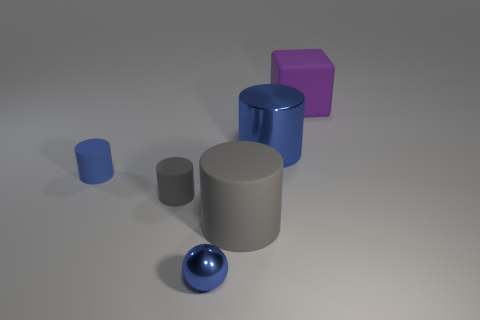Add 4 tiny cyan metal cubes. How many objects exist? 10 Subtract all blocks. How many objects are left? 5 Subtract 0 yellow cubes. How many objects are left? 6 Subtract all large matte cylinders. Subtract all rubber cylinders. How many objects are left? 2 Add 6 rubber things. How many rubber things are left? 10 Add 3 blue metal balls. How many blue metal balls exist? 4 